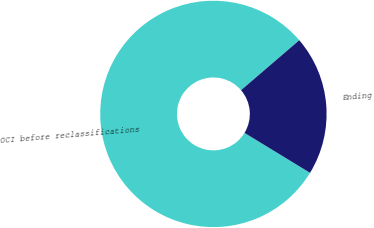Convert chart to OTSL. <chart><loc_0><loc_0><loc_500><loc_500><pie_chart><fcel>OCI before reclassifications<fcel>Ending<nl><fcel>80.0%<fcel>20.0%<nl></chart> 